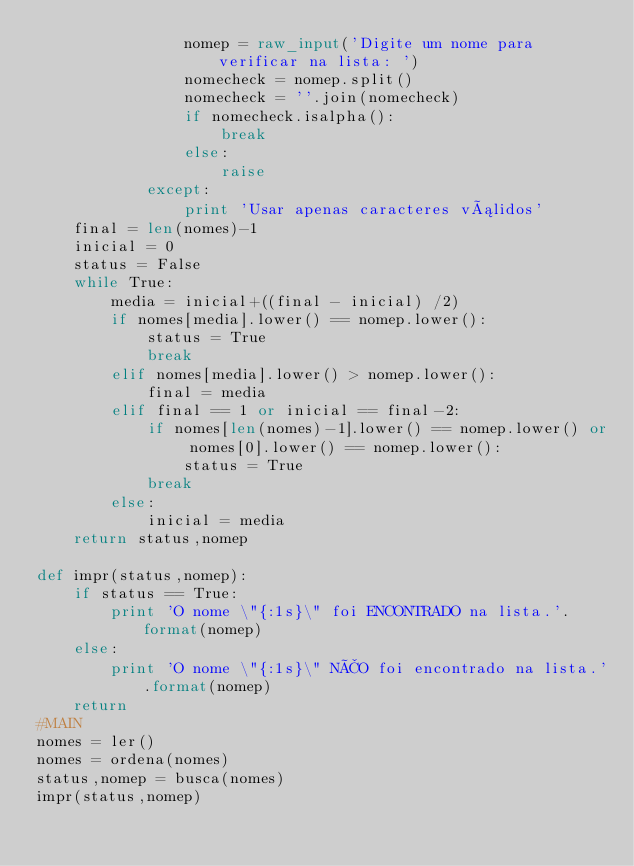Convert code to text. <code><loc_0><loc_0><loc_500><loc_500><_Python_>                nomep = raw_input('Digite um nome para verificar na lista: ')
                nomecheck = nomep.split()
                nomecheck = ''.join(nomecheck)
                if nomecheck.isalpha():                      
                    break
                else:
                    raise
            except:
                print 'Usar apenas caracteres válidos'
    final = len(nomes)-1
    inicial = 0
    status = False
    while True:
        media = inicial+((final - inicial) /2)
        if nomes[media].lower() == nomep.lower():
            status = True
            break
        elif nomes[media].lower() > nomep.lower():
            final = media
        elif final == 1 or inicial == final-2:
            if nomes[len(nomes)-1].lower() == nomep.lower() or nomes[0].lower() == nomep.lower():
                status = True
            break
        else:
            inicial = media
    return status,nomep

def impr(status,nomep):
    if status == True:
        print 'O nome \"{:1s}\" foi ENCONTRADO na lista.'.format(nomep)
    else:
        print 'O nome \"{:1s}\" NÃO foi encontrado na lista.'.format(nomep)
    return
#MAIN
nomes = ler()
nomes = ordena(nomes)
status,nomep = busca(nomes)
impr(status,nomep)

</code> 